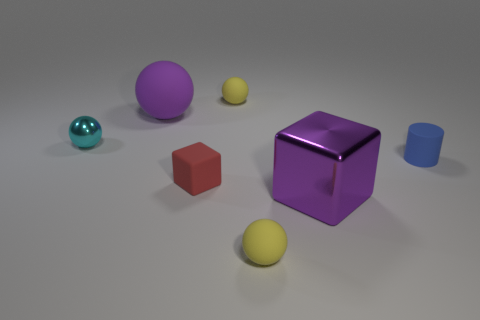Subtract all big purple balls. How many balls are left? 3 Add 2 small blocks. How many objects exist? 9 Subtract 1 balls. How many balls are left? 3 Subtract all brown cubes. How many yellow spheres are left? 2 Subtract all purple spheres. How many spheres are left? 3 Subtract all cylinders. How many objects are left? 6 Add 6 small metal spheres. How many small metal spheres are left? 7 Add 2 big metallic blocks. How many big metallic blocks exist? 3 Subtract 0 gray cylinders. How many objects are left? 7 Subtract all cyan cylinders. Subtract all brown cubes. How many cylinders are left? 1 